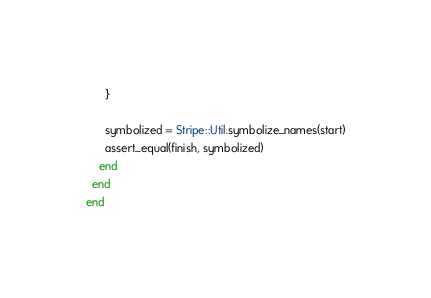Convert code to text. <code><loc_0><loc_0><loc_500><loc_500><_Ruby_>      }

      symbolized = Stripe::Util.symbolize_names(start)
      assert_equal(finish, symbolized)
    end
  end
end</code> 